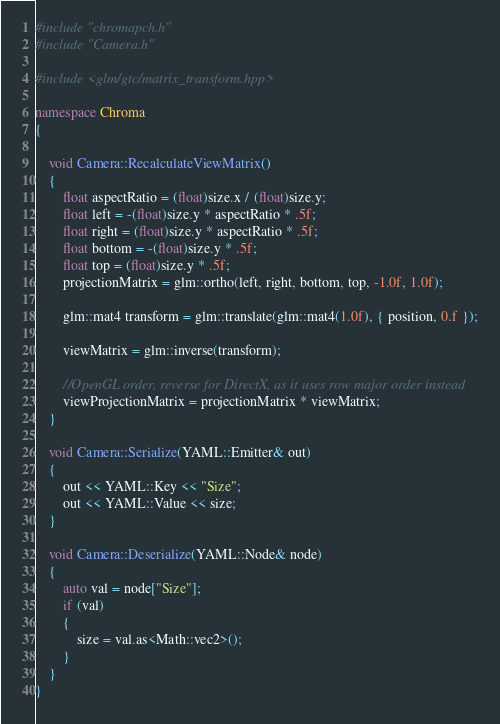<code> <loc_0><loc_0><loc_500><loc_500><_C++_>#include "chromapch.h"
#include "Camera.h"

#include <glm/gtc/matrix_transform.hpp>

namespace Chroma
{

	void Camera::RecalculateViewMatrix()
	{
		float aspectRatio = (float)size.x / (float)size.y;
		float left = -(float)size.y * aspectRatio * .5f;
		float right = (float)size.y * aspectRatio * .5f;
		float bottom = -(float)size.y * .5f;
		float top = (float)size.y * .5f;
		projectionMatrix = glm::ortho(left, right, bottom, top, -1.0f, 1.0f);

		glm::mat4 transform = glm::translate(glm::mat4(1.0f), { position, 0.f });

		viewMatrix = glm::inverse(transform);

		//OpenGL order, reverse for DirectX, as it uses row major order instead
		viewProjectionMatrix = projectionMatrix * viewMatrix;
	}

	void Camera::Serialize(YAML::Emitter& out)
	{
		out << YAML::Key << "Size";
		out << YAML::Value << size;
	}

	void Camera::Deserialize(YAML::Node& node)
	{
		auto val = node["Size"];
		if (val)
		{
			size = val.as<Math::vec2>();
		}
	}
}


</code> 